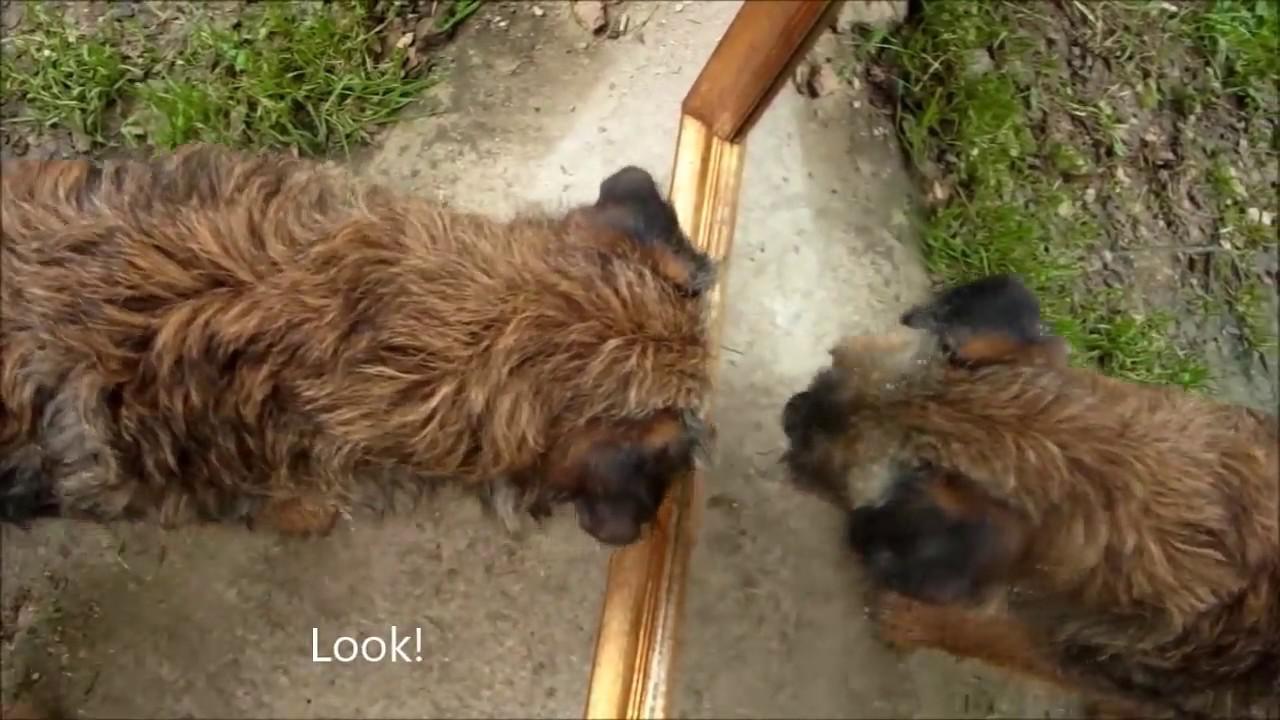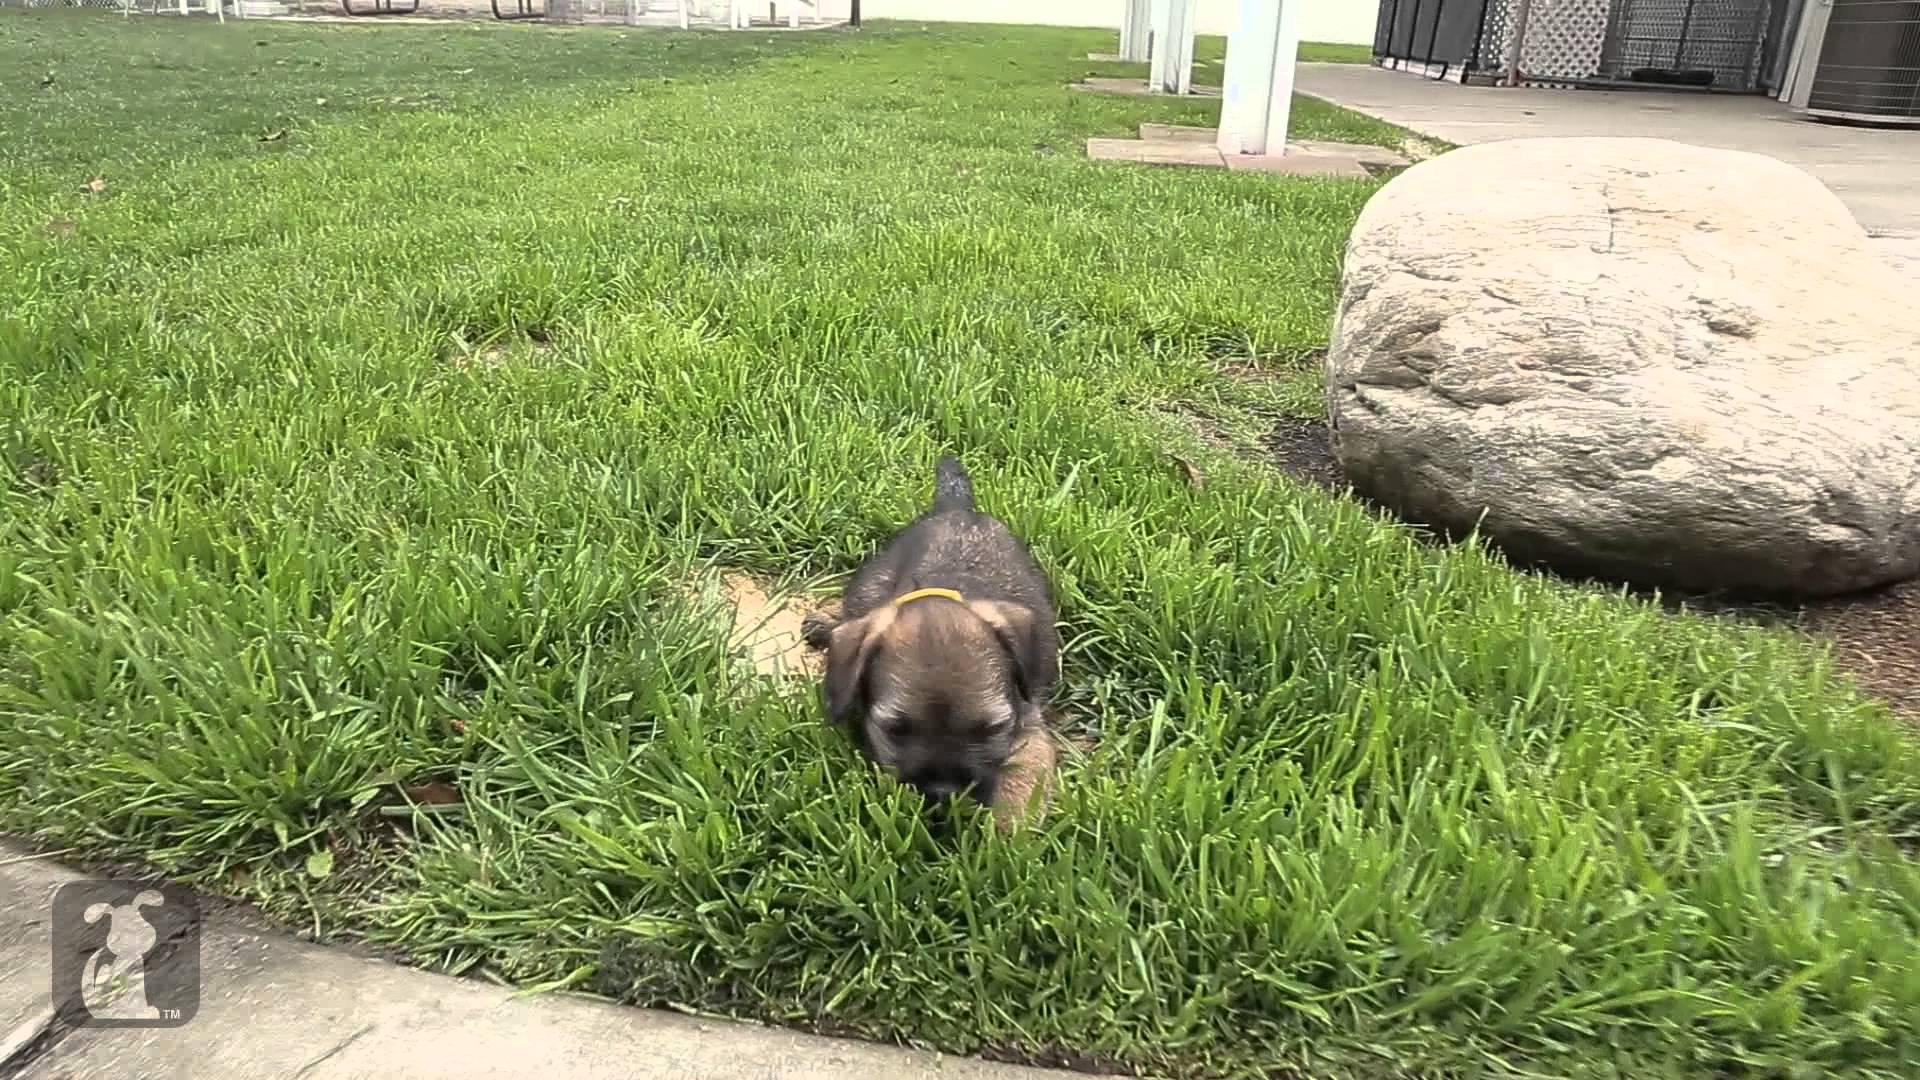The first image is the image on the left, the second image is the image on the right. For the images displayed, is the sentence "There are exactly two puppies, one in each image, and both of their faces are visible." factually correct? Answer yes or no. No. The first image is the image on the left, the second image is the image on the right. Evaluate the accuracy of this statement regarding the images: "The left and right image contains the same number of dogs with at least one sitting.". Is it true? Answer yes or no. No. 